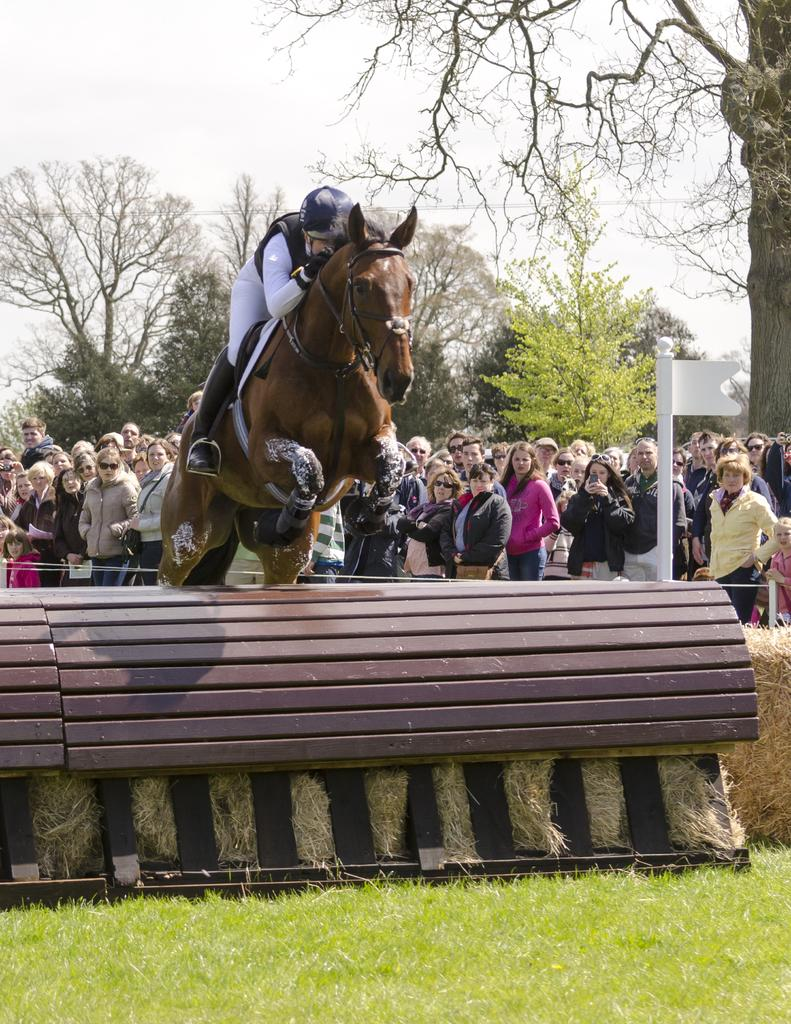What is the main subject of the image? The main subject of the image is a person riding a horse. What are the other people in the image doing? The other people are looking at the person riding the horse. What can be seen in the background of the image? Trees and the sky are visible in the background of the image. What type of steel is the horse made of in the image? The horse in the image is not made of steel; it is a living animal. What kind of trouble is the person riding the horse experiencing in the image? There is no indication of trouble for the person riding the horse in the image. 